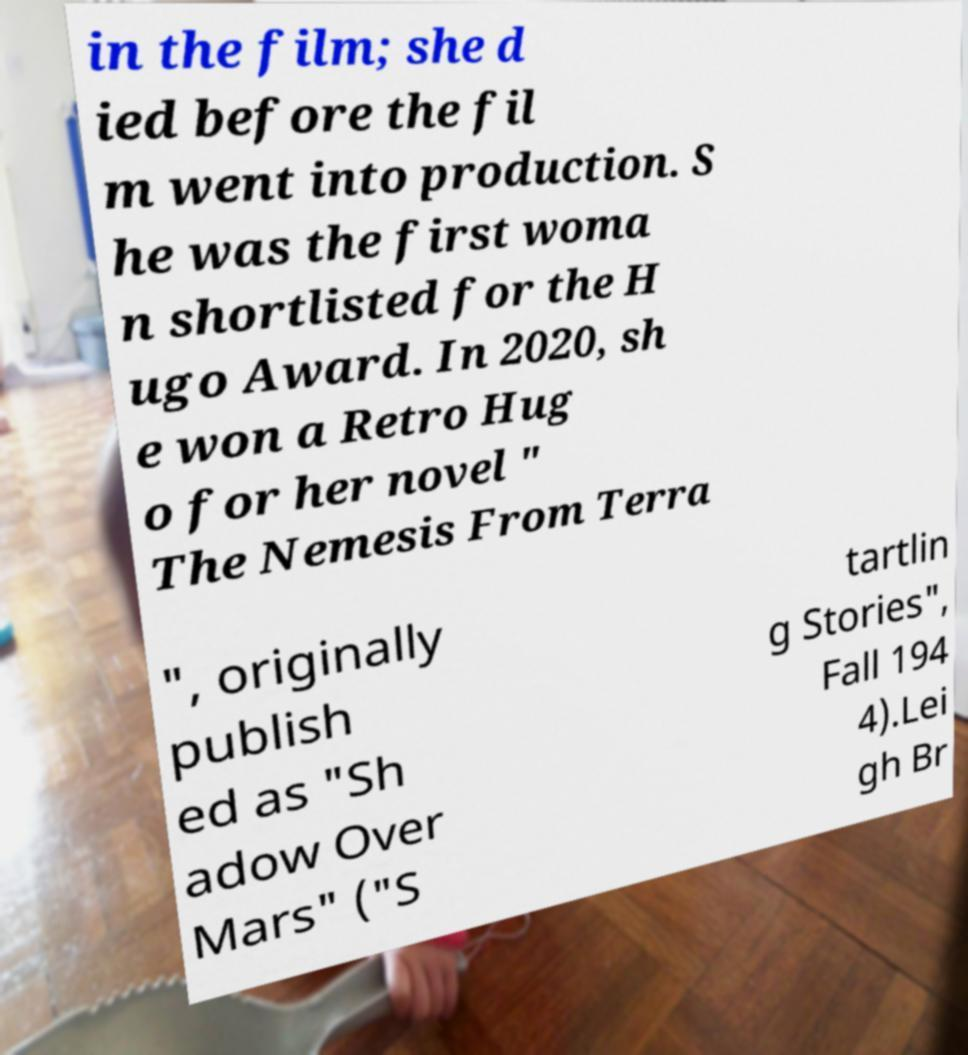There's text embedded in this image that I need extracted. Can you transcribe it verbatim? in the film; she d ied before the fil m went into production. S he was the first woma n shortlisted for the H ugo Award. In 2020, sh e won a Retro Hug o for her novel " The Nemesis From Terra ", originally publish ed as "Sh adow Over Mars" ("S tartlin g Stories", Fall 194 4).Lei gh Br 